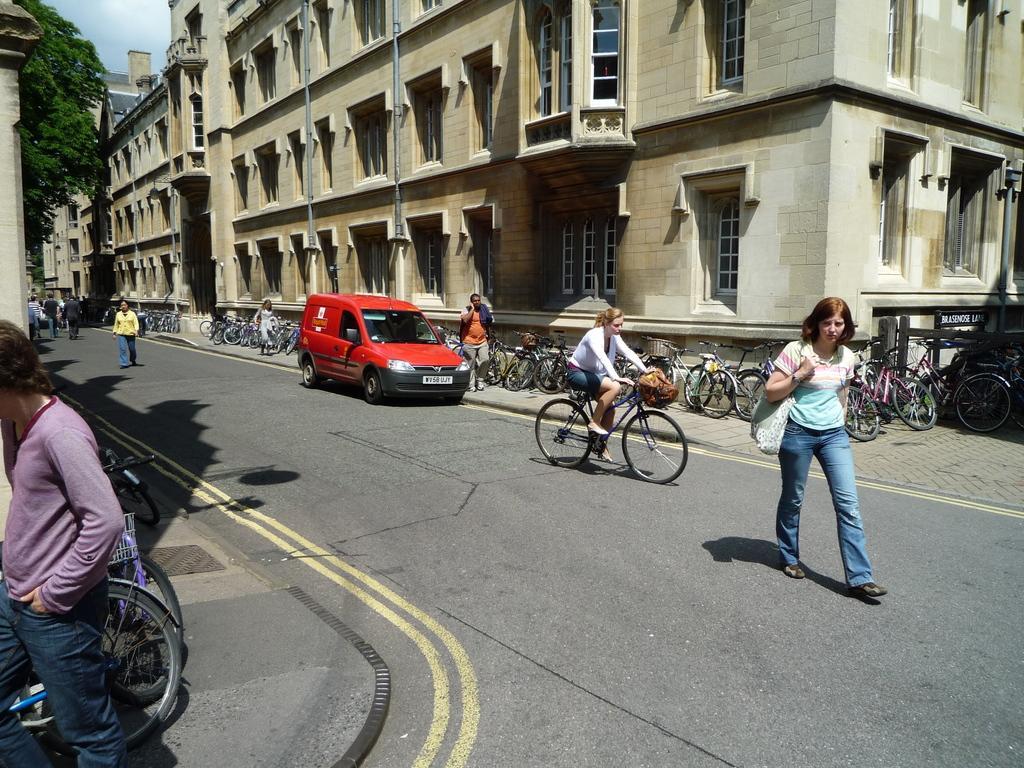How would you summarize this image in a sentence or two? In this picture I can see buildings and I can see trees and few people walking and I can see a woman riding bicycle and I can see few bicycles parked on the sidewalk and I can see a car on the road and I can see a cloudy sky. 